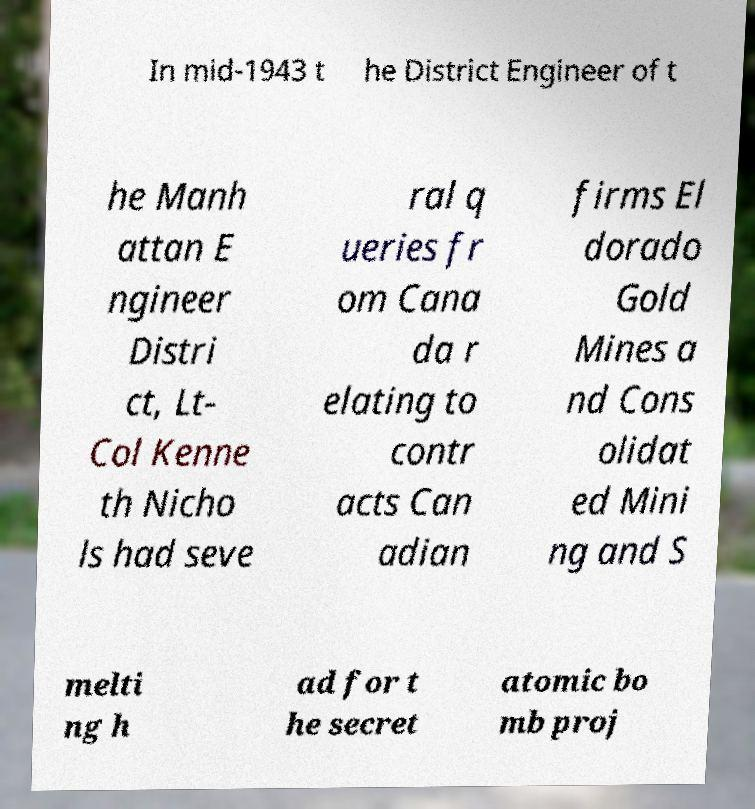There's text embedded in this image that I need extracted. Can you transcribe it verbatim? In mid-1943 t he District Engineer of t he Manh attan E ngineer Distri ct, Lt- Col Kenne th Nicho ls had seve ral q ueries fr om Cana da r elating to contr acts Can adian firms El dorado Gold Mines a nd Cons olidat ed Mini ng and S melti ng h ad for t he secret atomic bo mb proj 